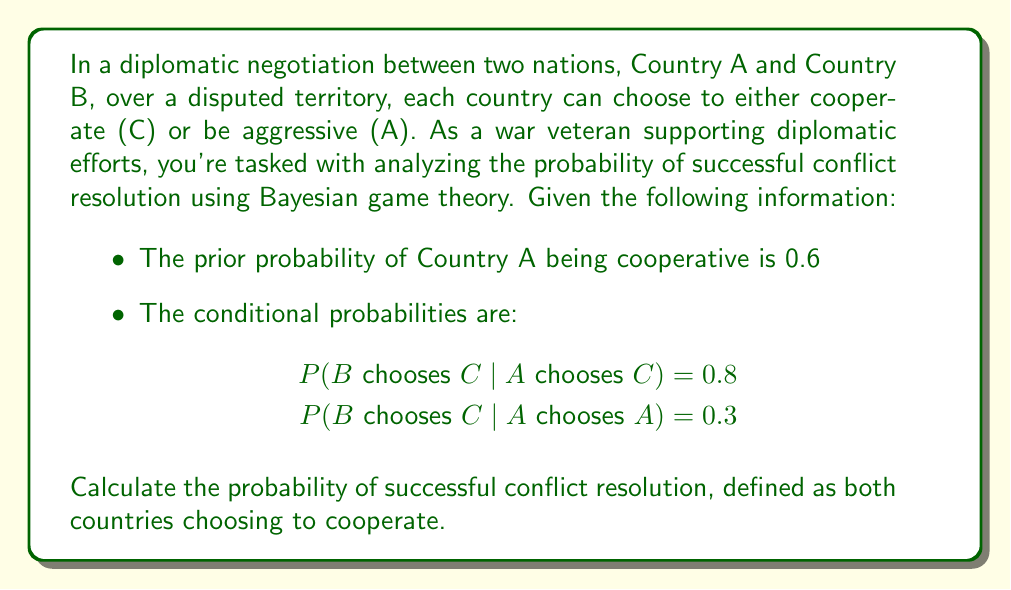Show me your answer to this math problem. To solve this problem using Bayesian game theory, we'll follow these steps:

1) Define events:
   Let $A_C$ = Country A chooses to cooperate
   Let $B_C$ = Country B chooses to cooperate

2) Given information:
   $P(A_C) = 0.6$
   $P(B_C|A_C) = 0.8$
   $P(B_C|A_A) = 0.3$, where $A_A$ is the event that Country A chooses to be aggressive

3) We need to find $P(A_C \cap B_C)$, which is the probability of both countries cooperating.

4) Using the law of total probability:
   $P(A_C \cap B_C) = P(B_C|A_C) \cdot P(A_C)$

5) Substituting the given values:
   $P(A_C \cap B_C) = 0.8 \cdot 0.6 = 0.48$

Therefore, the probability of successful conflict resolution (both countries cooperating) is 0.48 or 48%.

This analysis shows that despite the relatively high probability of Country A being cooperative (60%) and the high likelihood of Country B cooperating if Country A does (80%), the overall probability of successful resolution is less than 50%. This underscores the challenges in diplomatic negotiations and the importance of continued efforts to improve cooperation and communication between nations.
Answer: The probability of successful conflict resolution (both countries choosing to cooperate) is 0.48 or 48%. 